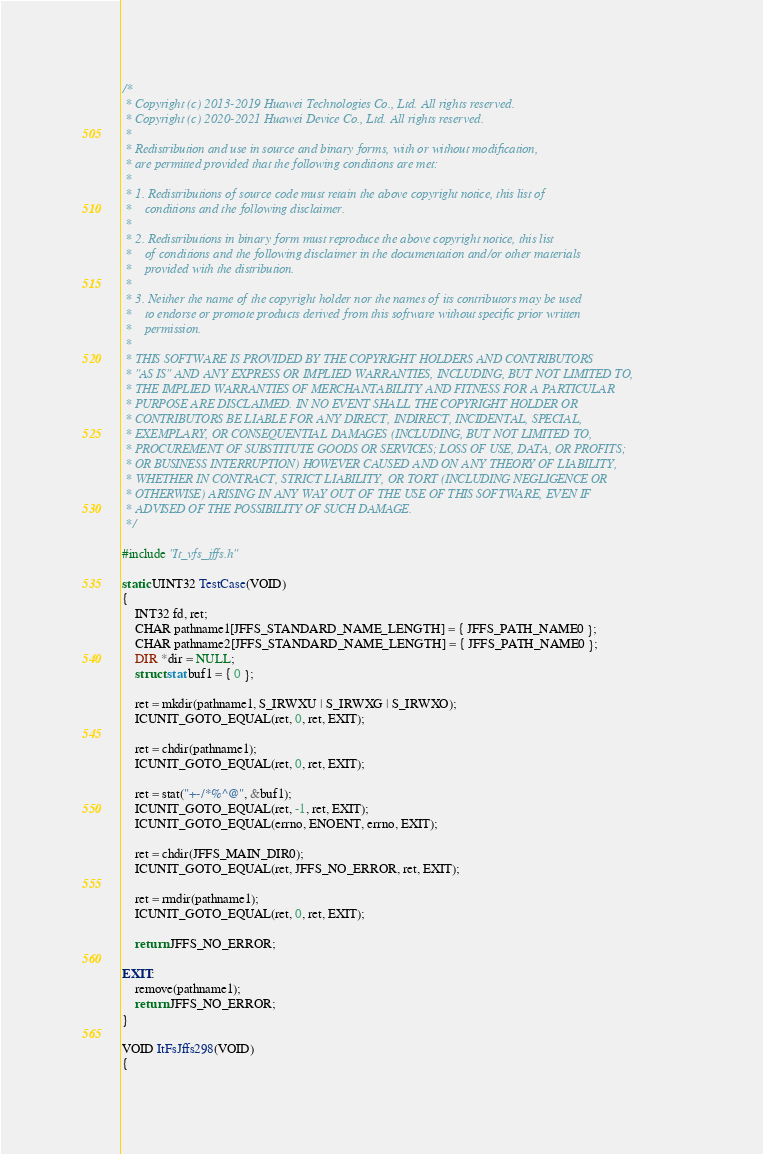<code> <loc_0><loc_0><loc_500><loc_500><_C++_>/*
 * Copyright (c) 2013-2019 Huawei Technologies Co., Ltd. All rights reserved.
 * Copyright (c) 2020-2021 Huawei Device Co., Ltd. All rights reserved.
 *
 * Redistribution and use in source and binary forms, with or without modification,
 * are permitted provided that the following conditions are met:
 *
 * 1. Redistributions of source code must retain the above copyright notice, this list of
 *    conditions and the following disclaimer.
 *
 * 2. Redistributions in binary form must reproduce the above copyright notice, this list
 *    of conditions and the following disclaimer in the documentation and/or other materials
 *    provided with the distribution.
 *
 * 3. Neither the name of the copyright holder nor the names of its contributors may be used
 *    to endorse or promote products derived from this software without specific prior written
 *    permission.
 *
 * THIS SOFTWARE IS PROVIDED BY THE COPYRIGHT HOLDERS AND CONTRIBUTORS
 * "AS IS" AND ANY EXPRESS OR IMPLIED WARRANTIES, INCLUDING, BUT NOT LIMITED TO,
 * THE IMPLIED WARRANTIES OF MERCHANTABILITY AND FITNESS FOR A PARTICULAR
 * PURPOSE ARE DISCLAIMED. IN NO EVENT SHALL THE COPYRIGHT HOLDER OR
 * CONTRIBUTORS BE LIABLE FOR ANY DIRECT, INDIRECT, INCIDENTAL, SPECIAL,
 * EXEMPLARY, OR CONSEQUENTIAL DAMAGES (INCLUDING, BUT NOT LIMITED TO,
 * PROCUREMENT OF SUBSTITUTE GOODS OR SERVICES; LOSS OF USE, DATA, OR PROFITS;
 * OR BUSINESS INTERRUPTION) HOWEVER CAUSED AND ON ANY THEORY OF LIABILITY,
 * WHETHER IN CONTRACT, STRICT LIABILITY, OR TORT (INCLUDING NEGLIGENCE OR
 * OTHERWISE) ARISING IN ANY WAY OUT OF THE USE OF THIS SOFTWARE, EVEN IF
 * ADVISED OF THE POSSIBILITY OF SUCH DAMAGE.
 */

#include "It_vfs_jffs.h"

static UINT32 TestCase(VOID)
{
    INT32 fd, ret;
    CHAR pathname1[JFFS_STANDARD_NAME_LENGTH] = { JFFS_PATH_NAME0 };
    CHAR pathname2[JFFS_STANDARD_NAME_LENGTH] = { JFFS_PATH_NAME0 };
    DIR *dir = NULL;
    struct stat buf1 = { 0 };

    ret = mkdir(pathname1, S_IRWXU | S_IRWXG | S_IRWXO);
    ICUNIT_GOTO_EQUAL(ret, 0, ret, EXIT);

    ret = chdir(pathname1);
    ICUNIT_GOTO_EQUAL(ret, 0, ret, EXIT);

    ret = stat("+-/*%^@", &buf1);
    ICUNIT_GOTO_EQUAL(ret, -1, ret, EXIT);
    ICUNIT_GOTO_EQUAL(errno, ENOENT, errno, EXIT);

    ret = chdir(JFFS_MAIN_DIR0);
    ICUNIT_GOTO_EQUAL(ret, JFFS_NO_ERROR, ret, EXIT);

    ret = rmdir(pathname1);
    ICUNIT_GOTO_EQUAL(ret, 0, ret, EXIT);

    return JFFS_NO_ERROR;

EXIT:
    remove(pathname1);
    return JFFS_NO_ERROR;
}

VOID ItFsJffs298(VOID)
{</code> 